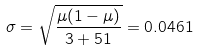Convert formula to latex. <formula><loc_0><loc_0><loc_500><loc_500>\sigma = \sqrt { \frac { \mu ( 1 - \mu ) } { 3 + 5 1 } } = 0 . 0 4 6 1</formula> 